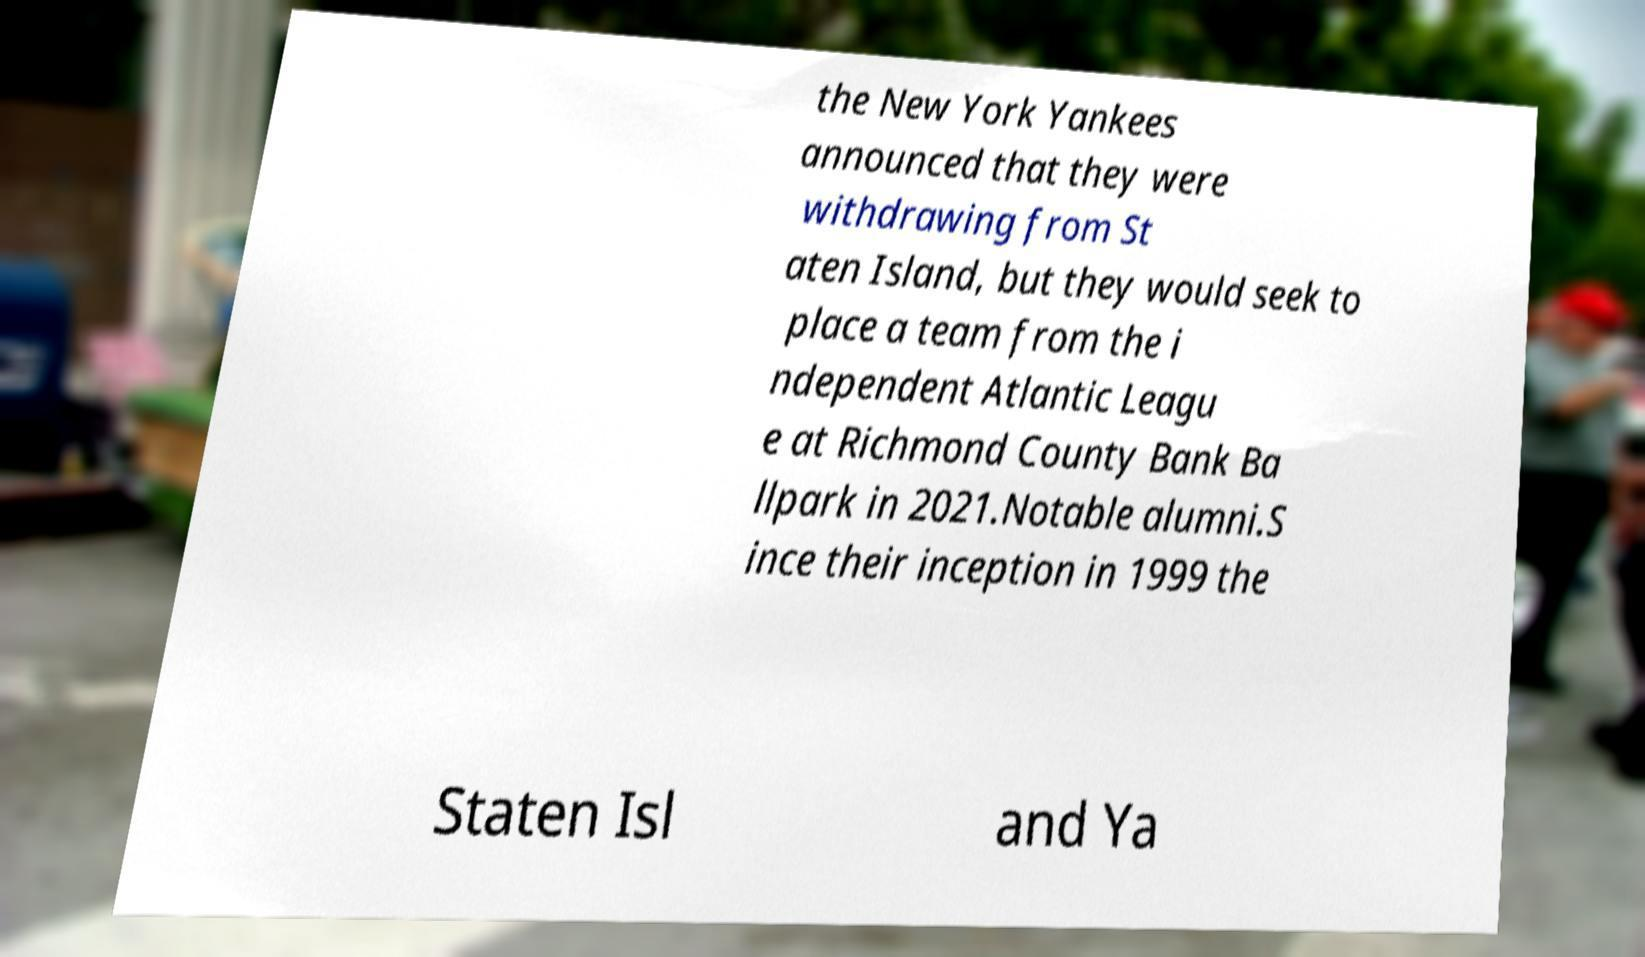Could you assist in decoding the text presented in this image and type it out clearly? the New York Yankees announced that they were withdrawing from St aten Island, but they would seek to place a team from the i ndependent Atlantic Leagu e at Richmond County Bank Ba llpark in 2021.Notable alumni.S ince their inception in 1999 the Staten Isl and Ya 